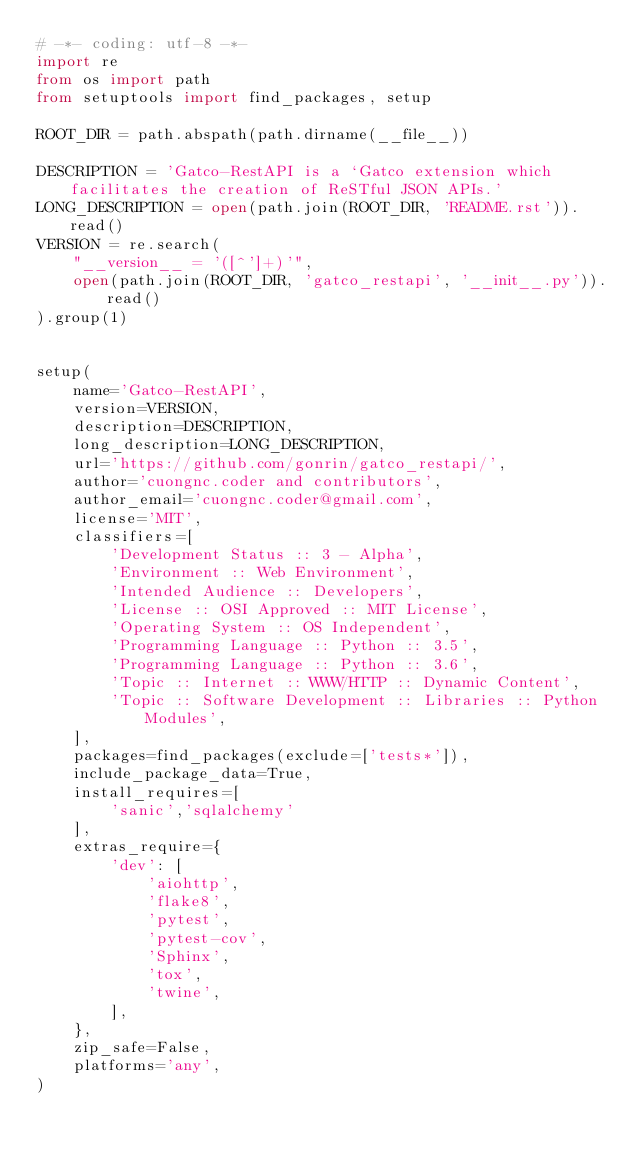Convert code to text. <code><loc_0><loc_0><loc_500><loc_500><_Python_># -*- coding: utf-8 -*-
import re
from os import path
from setuptools import find_packages, setup

ROOT_DIR = path.abspath(path.dirname(__file__))

DESCRIPTION = 'Gatco-RestAPI is a `Gatco extension which facilitates the creation of ReSTful JSON APIs.'
LONG_DESCRIPTION = open(path.join(ROOT_DIR, 'README.rst')).read()
VERSION = re.search(
    "__version__ = '([^']+)'",
    open(path.join(ROOT_DIR, 'gatco_restapi', '__init__.py')).read()
).group(1)


setup(
    name='Gatco-RestAPI',
    version=VERSION,
    description=DESCRIPTION,
    long_description=LONG_DESCRIPTION,
    url='https://github.com/gonrin/gatco_restapi/',
    author='cuongnc.coder and contributors',
    author_email='cuongnc.coder@gmail.com',
    license='MIT',
    classifiers=[
        'Development Status :: 3 - Alpha',
        'Environment :: Web Environment',
        'Intended Audience :: Developers',
        'License :: OSI Approved :: MIT License',
        'Operating System :: OS Independent',
        'Programming Language :: Python :: 3.5',
        'Programming Language :: Python :: 3.6',
        'Topic :: Internet :: WWW/HTTP :: Dynamic Content',
        'Topic :: Software Development :: Libraries :: Python Modules',
    ],
    packages=find_packages(exclude=['tests*']),
    include_package_data=True,
    install_requires=[
        'sanic','sqlalchemy'
    ],
    extras_require={
        'dev': [
            'aiohttp',
            'flake8',
            'pytest',
            'pytest-cov',
            'Sphinx',
            'tox',
            'twine',
        ],
    },
    zip_safe=False,
    platforms='any',
)
</code> 